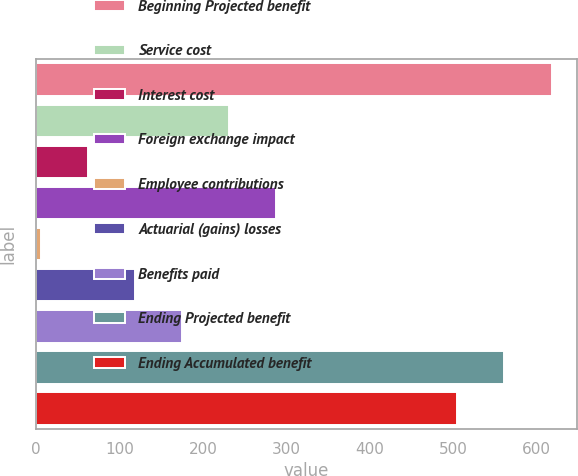<chart> <loc_0><loc_0><loc_500><loc_500><bar_chart><fcel>Beginning Projected benefit<fcel>Service cost<fcel>Interest cost<fcel>Foreign exchange impact<fcel>Employee contributions<fcel>Actuarial (gains) losses<fcel>Benefits paid<fcel>Ending Projected benefit<fcel>Ending Accumulated benefit<nl><fcel>617.8<fcel>231.6<fcel>62.4<fcel>288<fcel>6<fcel>118.8<fcel>175.2<fcel>561.4<fcel>505<nl></chart> 